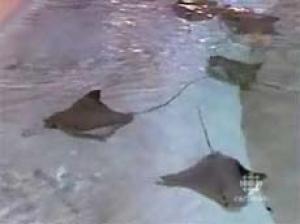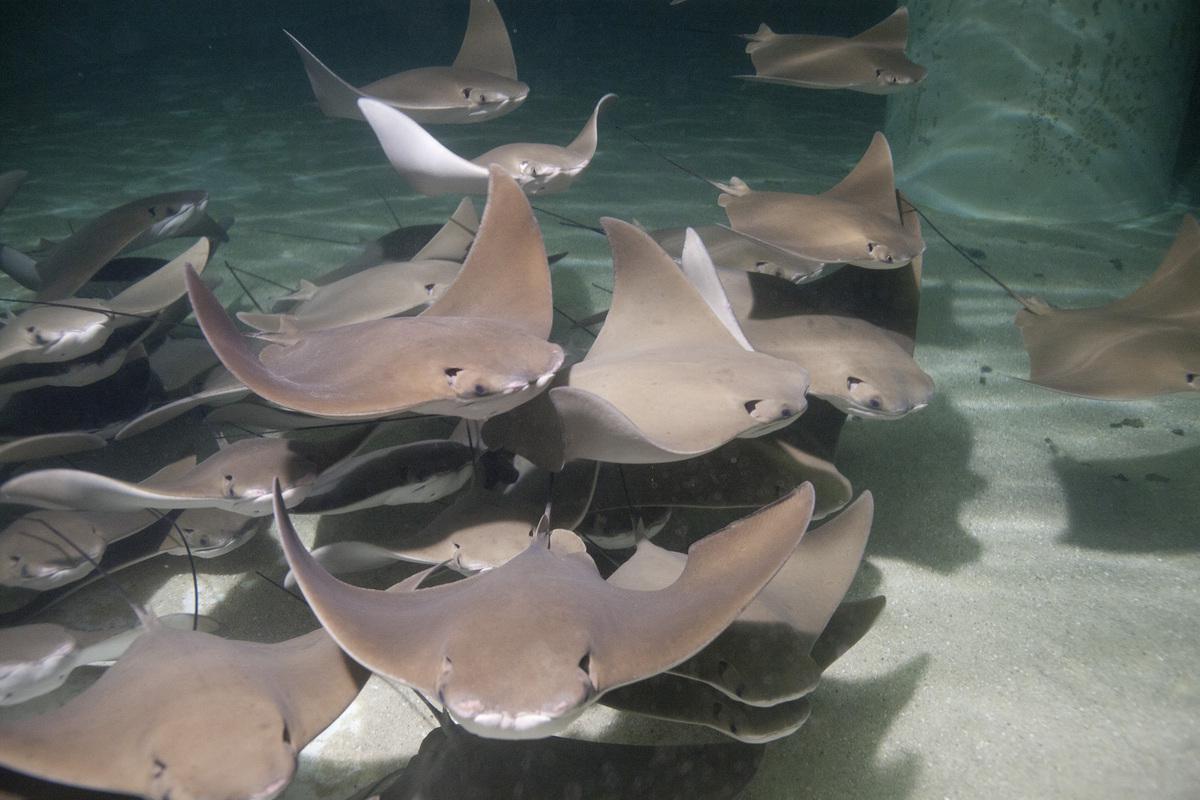The first image is the image on the left, the second image is the image on the right. For the images shown, is this caption "One stingray with its underside facing the camera is in the foreground of an image." true? Answer yes or no. No. The first image is the image on the left, the second image is the image on the right. For the images shown, is this caption "The underside of one of the rays in the water is visible in one of the images." true? Answer yes or no. No. 